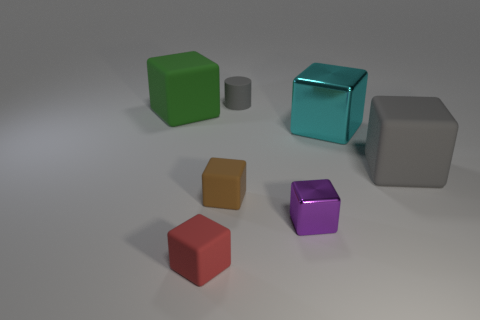Subtract 2 cubes. How many cubes are left? 4 Subtract all cyan cubes. How many cubes are left? 5 Subtract all tiny red cubes. How many cubes are left? 5 Subtract all green cubes. Subtract all purple cylinders. How many cubes are left? 5 Add 1 large rubber blocks. How many objects exist? 8 Subtract all cylinders. How many objects are left? 6 Add 3 green rubber objects. How many green rubber objects exist? 4 Subtract 0 cyan cylinders. How many objects are left? 7 Subtract all cyan blocks. Subtract all blocks. How many objects are left? 0 Add 3 green things. How many green things are left? 4 